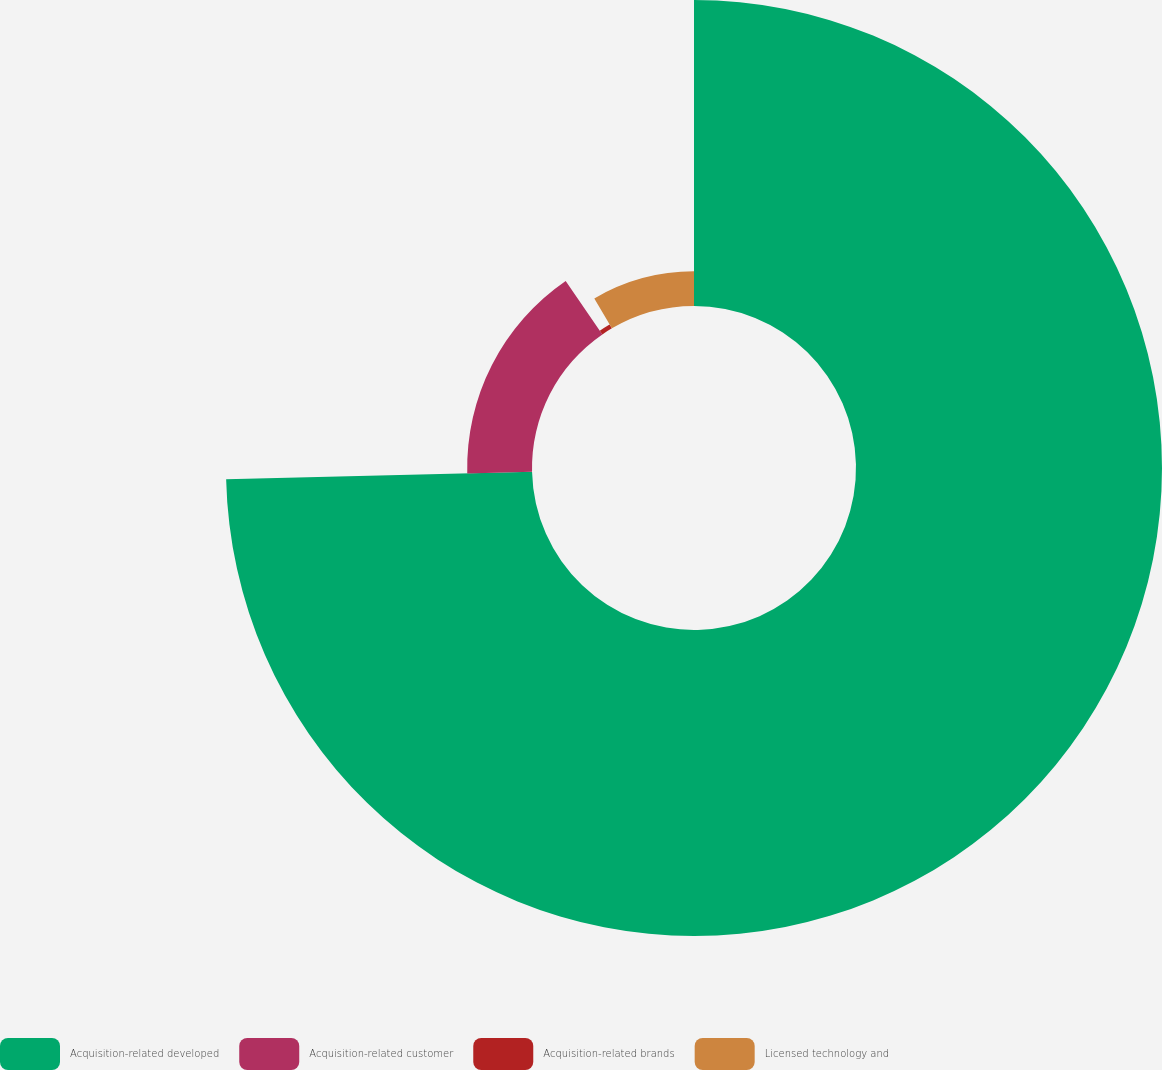Convert chart. <chart><loc_0><loc_0><loc_500><loc_500><pie_chart><fcel>Acquisition-related developed<fcel>Acquisition-related customer<fcel>Acquisition-related brands<fcel>Licensed technology and<nl><fcel>74.62%<fcel>15.81%<fcel>1.11%<fcel>8.46%<nl></chart> 